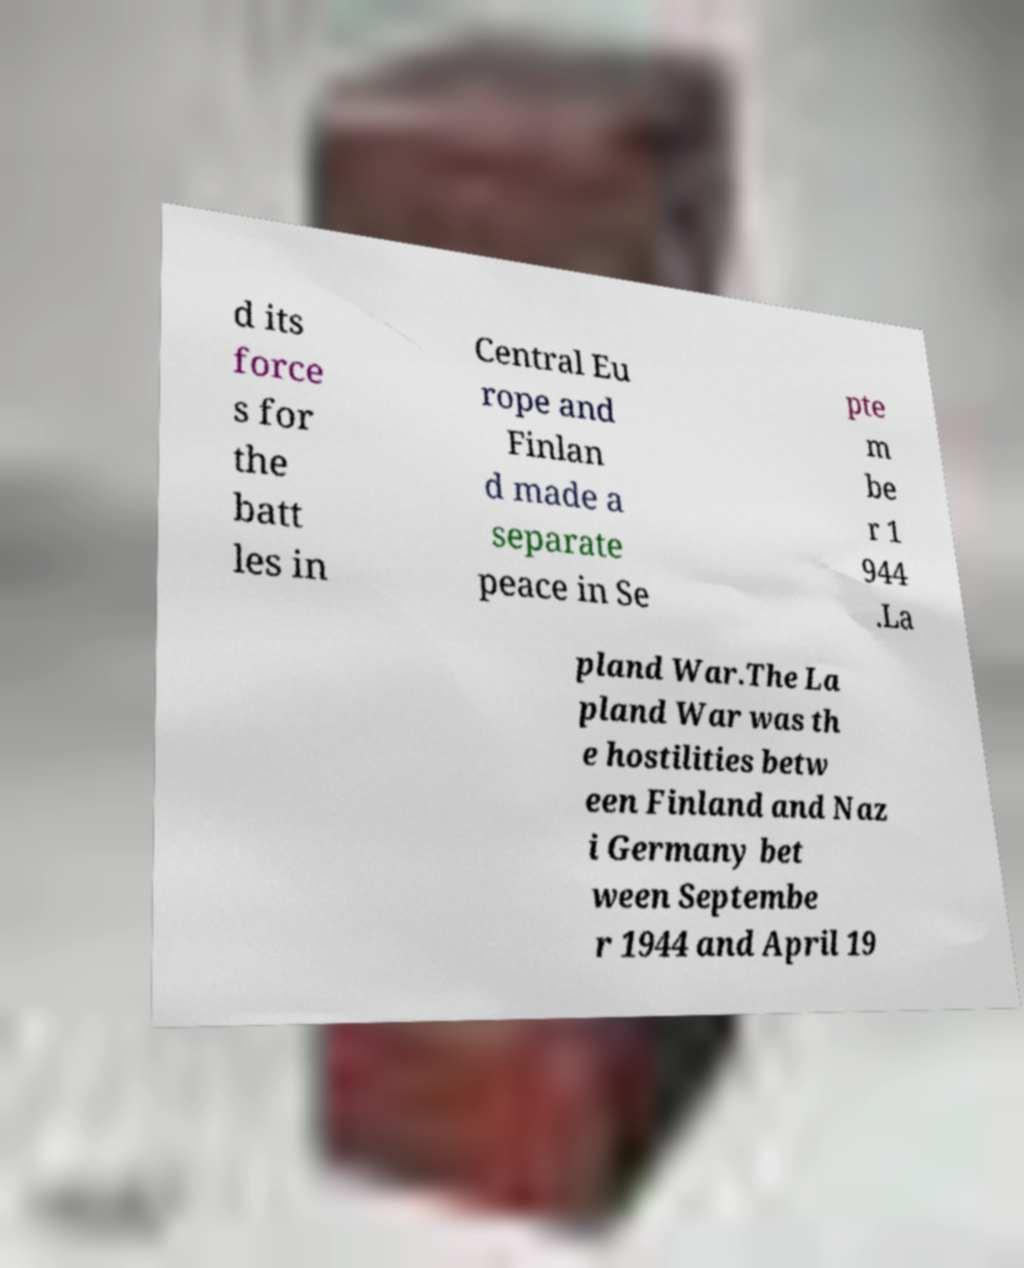Can you read and provide the text displayed in the image?This photo seems to have some interesting text. Can you extract and type it out for me? d its force s for the batt les in Central Eu rope and Finlan d made a separate peace in Se pte m be r 1 944 .La pland War.The La pland War was th e hostilities betw een Finland and Naz i Germany bet ween Septembe r 1944 and April 19 